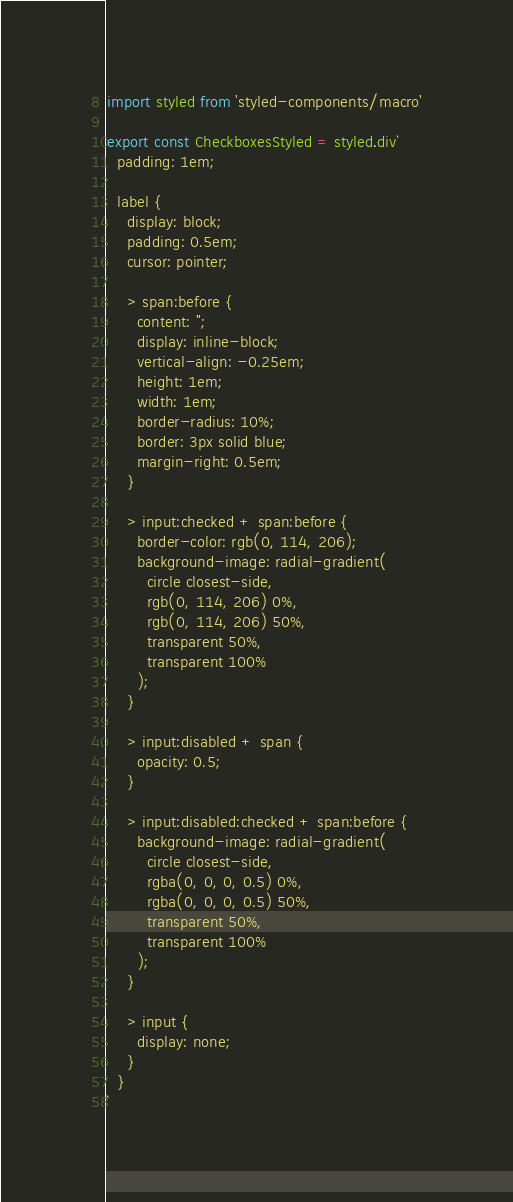<code> <loc_0><loc_0><loc_500><loc_500><_TypeScript_>import styled from 'styled-components/macro'

export const CheckboxesStyled = styled.div`
  padding: 1em;

  label {
    display: block;
    padding: 0.5em;
    cursor: pointer;

    > span:before {
      content: '';
      display: inline-block;
      vertical-align: -0.25em;
      height: 1em;
      width: 1em;
      border-radius: 10%;
      border: 3px solid blue;
      margin-right: 0.5em;
    }

    > input:checked + span:before {
      border-color: rgb(0, 114, 206);
      background-image: radial-gradient(
        circle closest-side,
        rgb(0, 114, 206) 0%,
        rgb(0, 114, 206) 50%,
        transparent 50%,
        transparent 100%
      );
    }

    > input:disabled + span {
      opacity: 0.5;
    }

    > input:disabled:checked + span:before {
      background-image: radial-gradient(
        circle closest-side,
        rgba(0, 0, 0, 0.5) 0%,
        rgba(0, 0, 0, 0.5) 50%,
        transparent 50%,
        transparent 100%
      );
    }

    > input {
      display: none;
    }
  }
`
</code> 